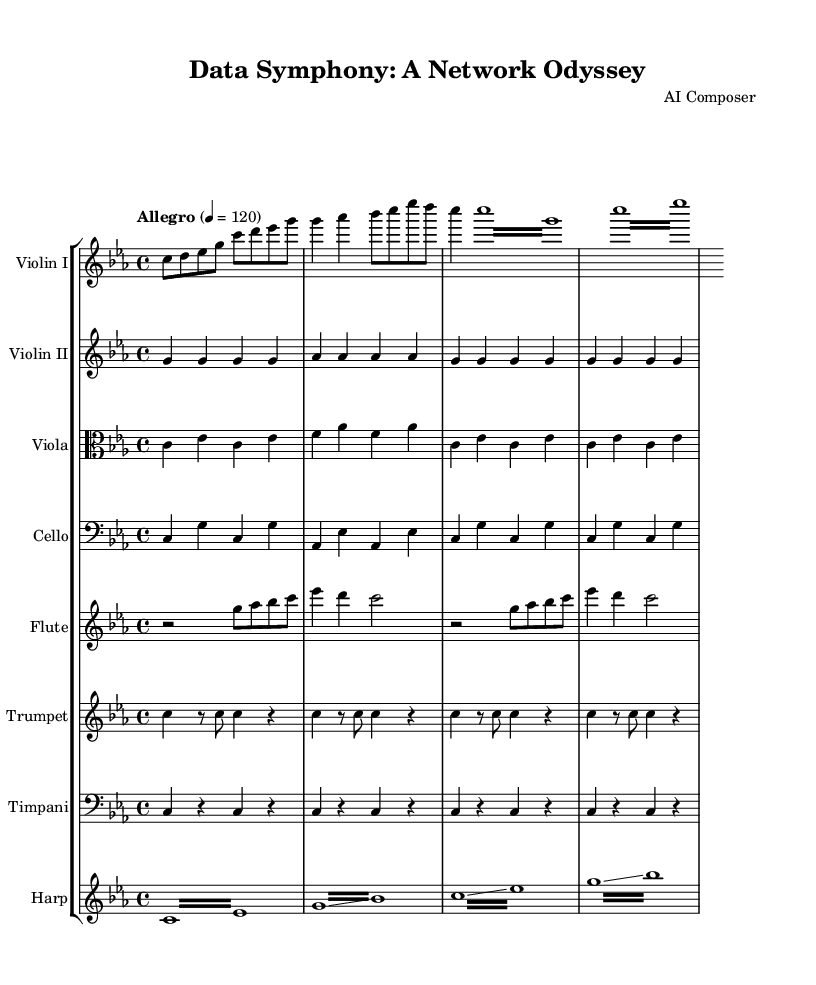What is the key signature of this music? The key signature is C minor, which includes three flats (B flat, E flat, and A flat). This can be identified by looking at the key signature at the beginning of the staff.
Answer: C minor What is the time signature of the piece? The time signature is 4/4, which indicates that there are four beats in each measure and the quarter note receives one beat. This can be found written at the beginning of the score.
Answer: 4/4 What is the tempo marking of the composition? The tempo marking is "Allegro" with a metronome marking of 120 beats per minute, indicated at the beginning of the score.
Answer: Allegro Which instrument has the melodic embellishment? The flute has the melodic embellishment, as indicated by the specific rhythmic and pitch patterns that are distinctively more ornamented compared to others.
Answer: Flute How many measures are in the violin I part? The violin I part consists of eight measures, as can be counted from the notation provided in the segment for that instrument.
Answer: Eight What is the role of the timpani in this symphony? The timpani plays a rhythmic pulse, providing a heartbeat-like effect that reinforces the foundational beat throughout the symphony. This can be inferred by analyzing the consistent quarter note rhythms they play in the score.
Answer: Rhythmic pulse What does the harp represent in this symphonic piece? The harp represents data flow, which is depicted through its glissando and tremolo sections that suggest smooth and quick transitions, symbolizing rapid movement of information. This interpretation arises from the musical elements present in the harp part.
Answer: Data flow 